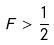Convert formula to latex. <formula><loc_0><loc_0><loc_500><loc_500>F > \frac { 1 } { 2 }</formula> 